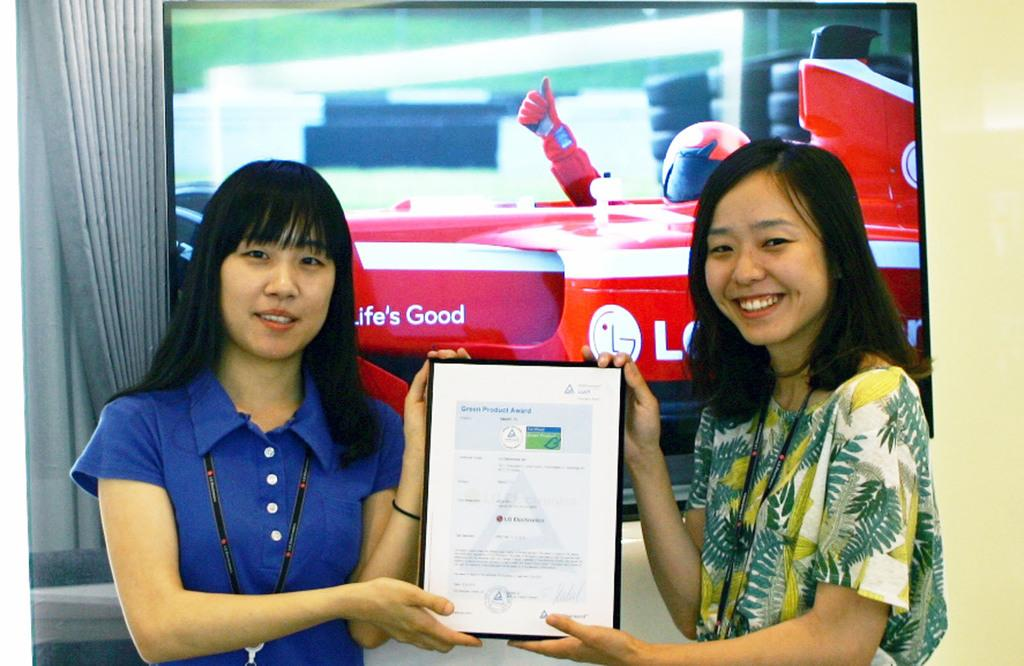How many people are in the image? There are two ladies in the image. What are the ladies doing in the image? The ladies are standing and smiling. What are the ladies holding in the image? The ladies are holding a paper. What can be seen in the background of the image? There is a screen in the background of the image. What is present on the left side of the image? There is a curtain on the left side of the image. What type of map can be seen in the image? There is no map present in the image. What fictional character might the ladies be discussing in the image? The image does not provide any information about a fictional character or a discussion about one. 